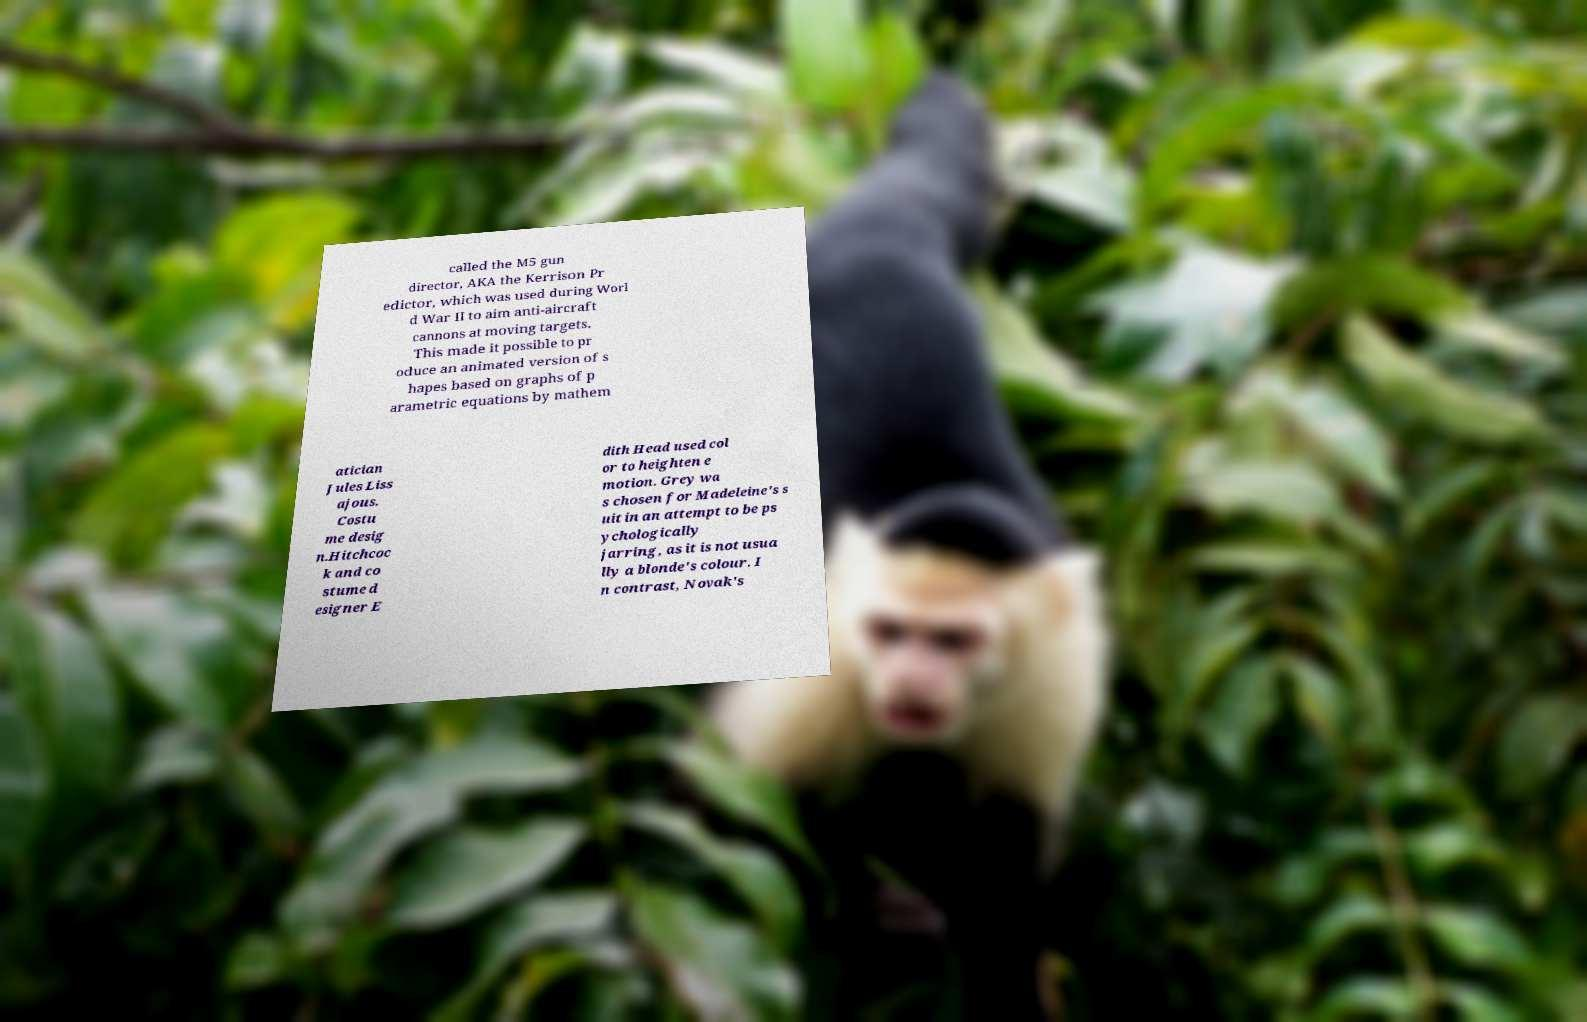Could you extract and type out the text from this image? called the M5 gun director, AKA the Kerrison Pr edictor, which was used during Worl d War II to aim anti-aircraft cannons at moving targets. This made it possible to pr oduce an animated version of s hapes based on graphs of p arametric equations by mathem atician Jules Liss ajous. Costu me desig n.Hitchcoc k and co stume d esigner E dith Head used col or to heighten e motion. Grey wa s chosen for Madeleine's s uit in an attempt to be ps ychologically jarring, as it is not usua lly a blonde's colour. I n contrast, Novak's 